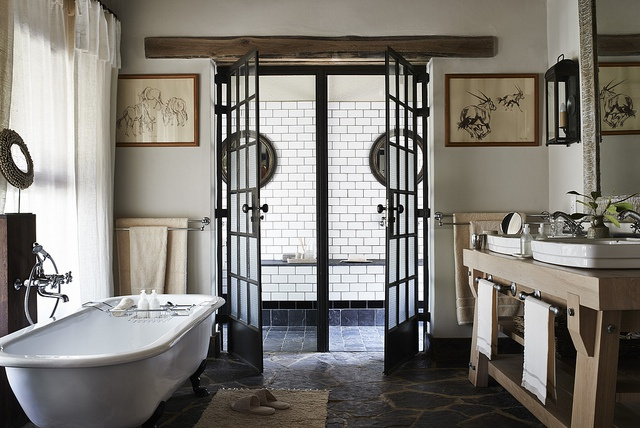Describe the objects in this image and their specific colors. I can see sink in gray, lightgray, darkgray, and black tones, potted plant in gray, black, darkgray, and darkgreen tones, sink in gray, lightgray, darkgray, and black tones, horse in gray and tan tones, and horse in gray, tan, and lightgray tones in this image. 